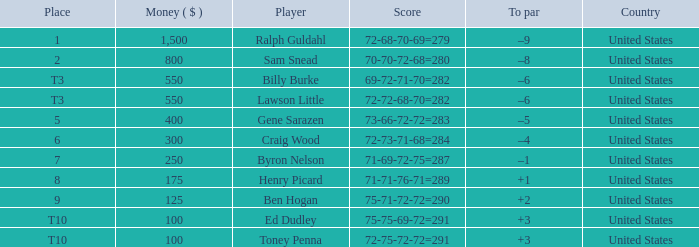Which score has a prize of $400? 73-66-72-72=283. 